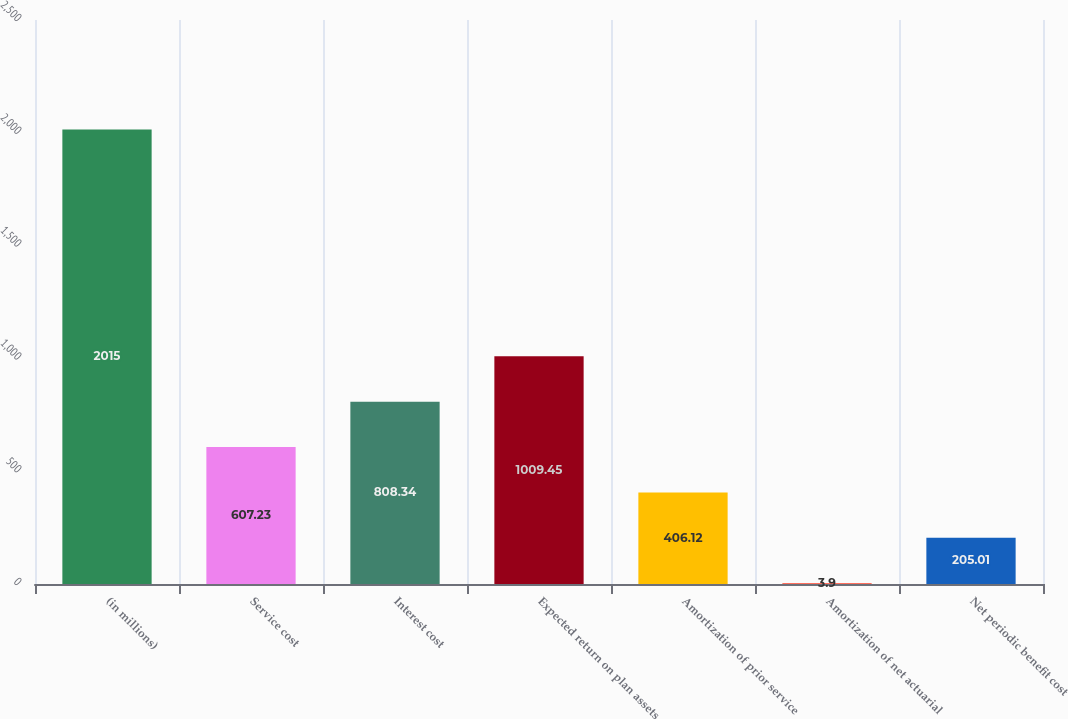Convert chart. <chart><loc_0><loc_0><loc_500><loc_500><bar_chart><fcel>(in millions)<fcel>Service cost<fcel>Interest cost<fcel>Expected return on plan assets<fcel>Amortization of prior service<fcel>Amortization of net actuarial<fcel>Net periodic benefit cost<nl><fcel>2015<fcel>607.23<fcel>808.34<fcel>1009.45<fcel>406.12<fcel>3.9<fcel>205.01<nl></chart> 